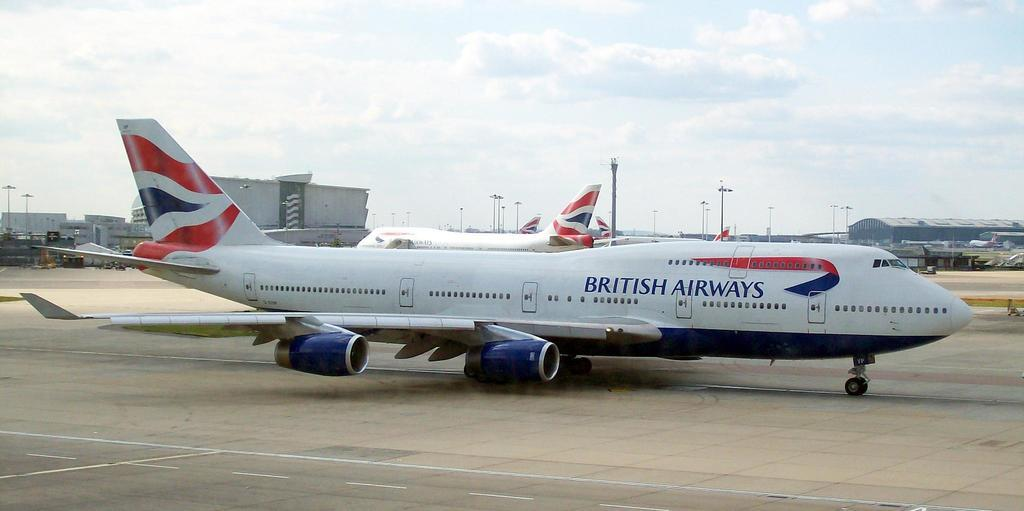<image>
Present a compact description of the photo's key features. A red, white and blue British Airways airplane is parked on a runway. 